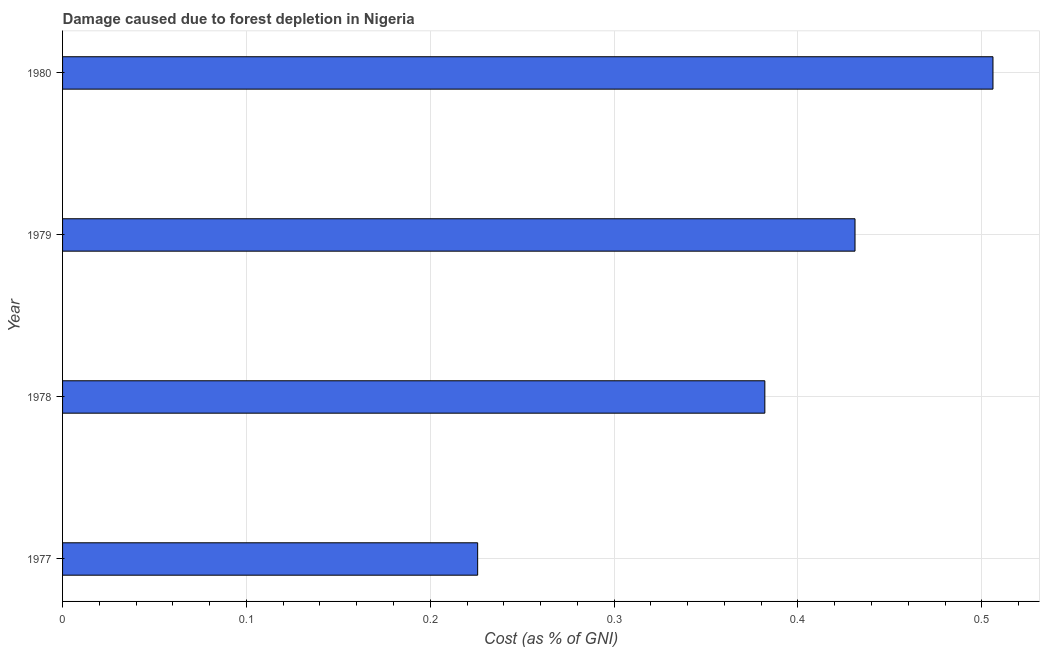Does the graph contain any zero values?
Your response must be concise. No. What is the title of the graph?
Your response must be concise. Damage caused due to forest depletion in Nigeria. What is the label or title of the X-axis?
Keep it short and to the point. Cost (as % of GNI). What is the label or title of the Y-axis?
Make the answer very short. Year. What is the damage caused due to forest depletion in 1980?
Your response must be concise. 0.51. Across all years, what is the maximum damage caused due to forest depletion?
Offer a very short reply. 0.51. Across all years, what is the minimum damage caused due to forest depletion?
Your answer should be compact. 0.23. In which year was the damage caused due to forest depletion maximum?
Provide a succinct answer. 1980. What is the sum of the damage caused due to forest depletion?
Make the answer very short. 1.54. What is the difference between the damage caused due to forest depletion in 1977 and 1978?
Ensure brevity in your answer.  -0.16. What is the average damage caused due to forest depletion per year?
Your answer should be very brief. 0.39. What is the median damage caused due to forest depletion?
Your answer should be very brief. 0.41. In how many years, is the damage caused due to forest depletion greater than 0.38 %?
Make the answer very short. 3. What is the ratio of the damage caused due to forest depletion in 1978 to that in 1980?
Provide a succinct answer. 0.76. What is the difference between the highest and the second highest damage caused due to forest depletion?
Provide a succinct answer. 0.07. Is the sum of the damage caused due to forest depletion in 1978 and 1979 greater than the maximum damage caused due to forest depletion across all years?
Your answer should be very brief. Yes. What is the difference between the highest and the lowest damage caused due to forest depletion?
Offer a terse response. 0.28. In how many years, is the damage caused due to forest depletion greater than the average damage caused due to forest depletion taken over all years?
Provide a short and direct response. 2. What is the Cost (as % of GNI) of 1977?
Give a very brief answer. 0.23. What is the Cost (as % of GNI) in 1978?
Your response must be concise. 0.38. What is the Cost (as % of GNI) in 1979?
Your response must be concise. 0.43. What is the Cost (as % of GNI) in 1980?
Offer a terse response. 0.51. What is the difference between the Cost (as % of GNI) in 1977 and 1978?
Your response must be concise. -0.16. What is the difference between the Cost (as % of GNI) in 1977 and 1979?
Give a very brief answer. -0.21. What is the difference between the Cost (as % of GNI) in 1977 and 1980?
Your answer should be compact. -0.28. What is the difference between the Cost (as % of GNI) in 1978 and 1979?
Provide a succinct answer. -0.05. What is the difference between the Cost (as % of GNI) in 1978 and 1980?
Provide a short and direct response. -0.12. What is the difference between the Cost (as % of GNI) in 1979 and 1980?
Your response must be concise. -0.08. What is the ratio of the Cost (as % of GNI) in 1977 to that in 1978?
Ensure brevity in your answer.  0.59. What is the ratio of the Cost (as % of GNI) in 1977 to that in 1979?
Ensure brevity in your answer.  0.52. What is the ratio of the Cost (as % of GNI) in 1977 to that in 1980?
Your response must be concise. 0.45. What is the ratio of the Cost (as % of GNI) in 1978 to that in 1979?
Give a very brief answer. 0.89. What is the ratio of the Cost (as % of GNI) in 1978 to that in 1980?
Keep it short and to the point. 0.76. What is the ratio of the Cost (as % of GNI) in 1979 to that in 1980?
Keep it short and to the point. 0.85. 